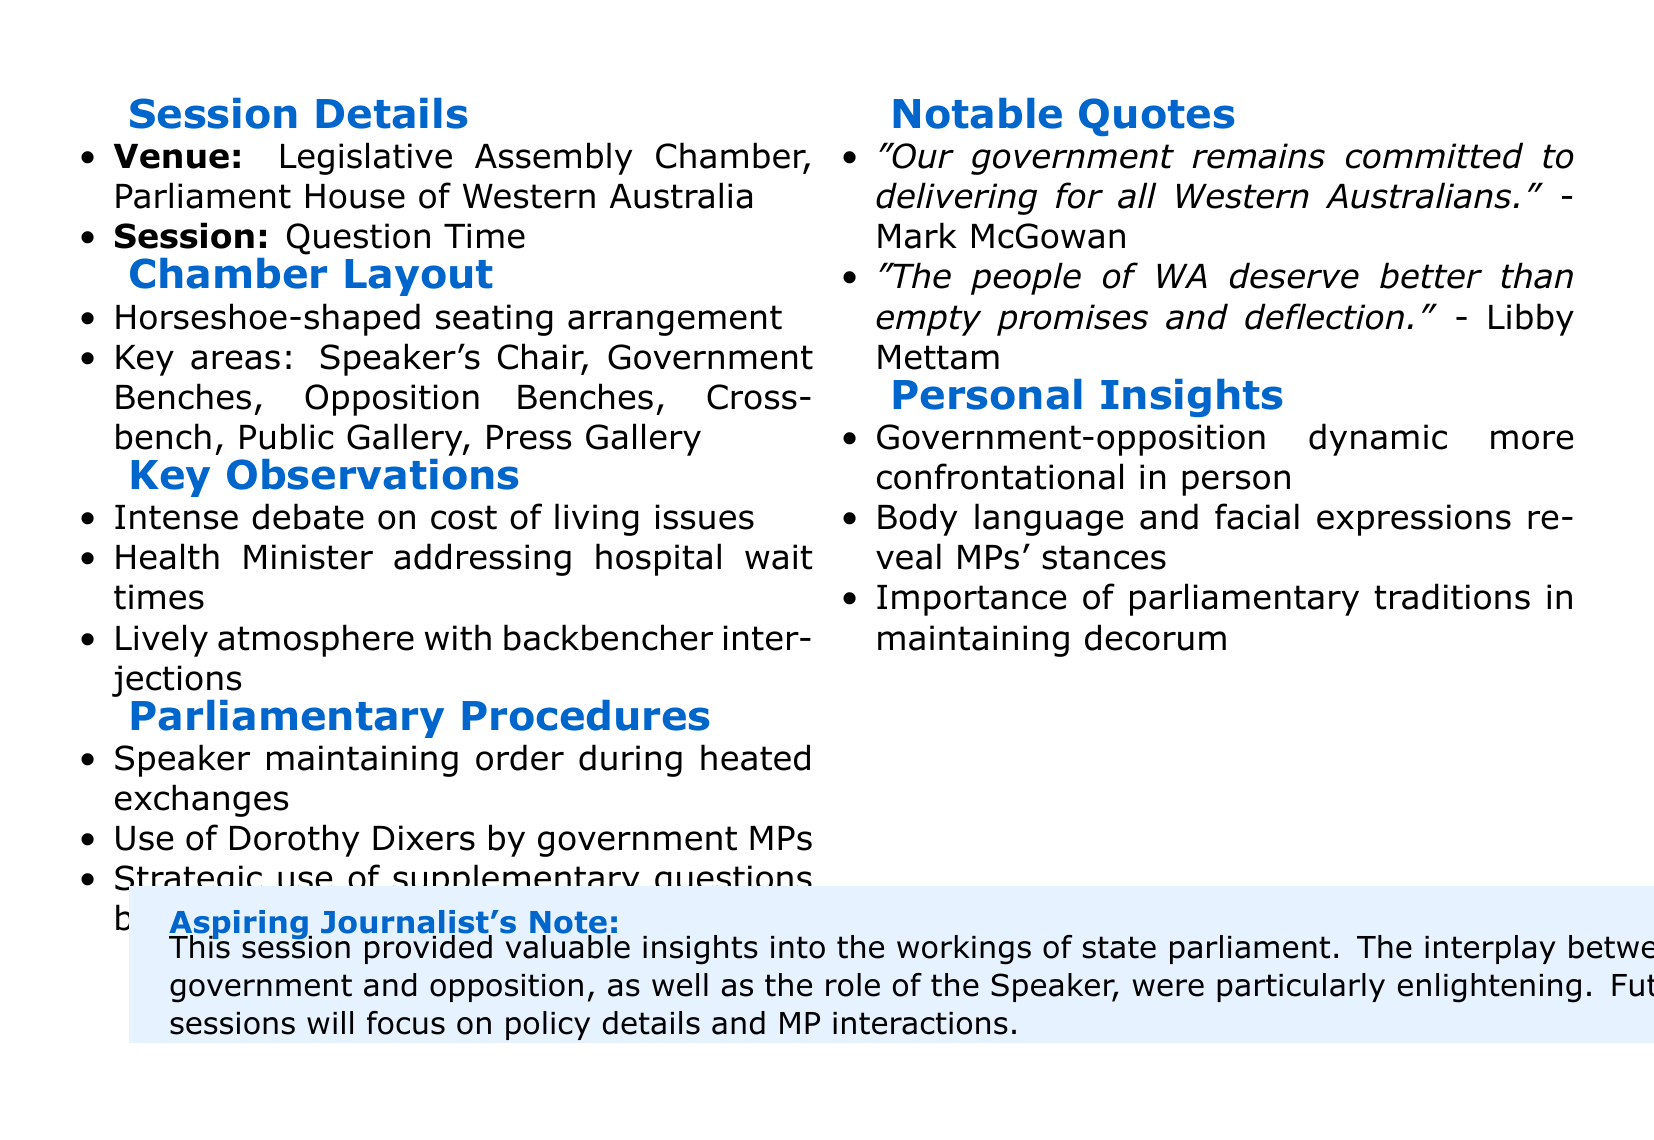What date was the session held? The date of the session is explicitly mentioned in the document as May 15, 2023.
Answer: May 15, 2023 What is the name of the venue? The venue name is provided in the session details section as the Legislative Assembly Chamber, Parliament House of Western Australia.
Answer: Legislative Assembly Chamber, Parliament House of Western Australia Who are the key speakers mentioned in the notable quotes? The notable quotes include statements from Mark McGowan and Libby Mettam, highlighting their importance in the session.
Answer: Mark McGowan, Libby Mettam What observation was made regarding the debate topics? The document notes intense debate specifically concerning cost of living issues, which is a significant point of interest during the session.
Answer: Cost of living issues Which role did Speaker Rita Saffioti play during the session? Speaker Rita Saffioti is mentioned in the context of maintaining order during heated exchanges, underscoring her responsibility in the proceedings.
Answer: Maintaining order What was one personal insight gained from attending the session? The insights highlight the dynamic relationship between government and opposition, revealing the confrontational nature observed firsthand.
Answer: Confrontational dynamic 